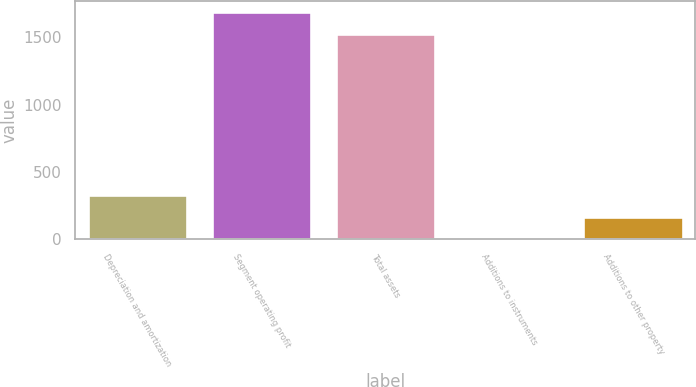Convert chart to OTSL. <chart><loc_0><loc_0><loc_500><loc_500><bar_chart><fcel>Depreciation and amortization<fcel>Segment operating profit<fcel>Total assets<fcel>Additions to instruments<fcel>Additions to other property<nl><fcel>330.68<fcel>1689.54<fcel>1525<fcel>1.6<fcel>166.14<nl></chart> 